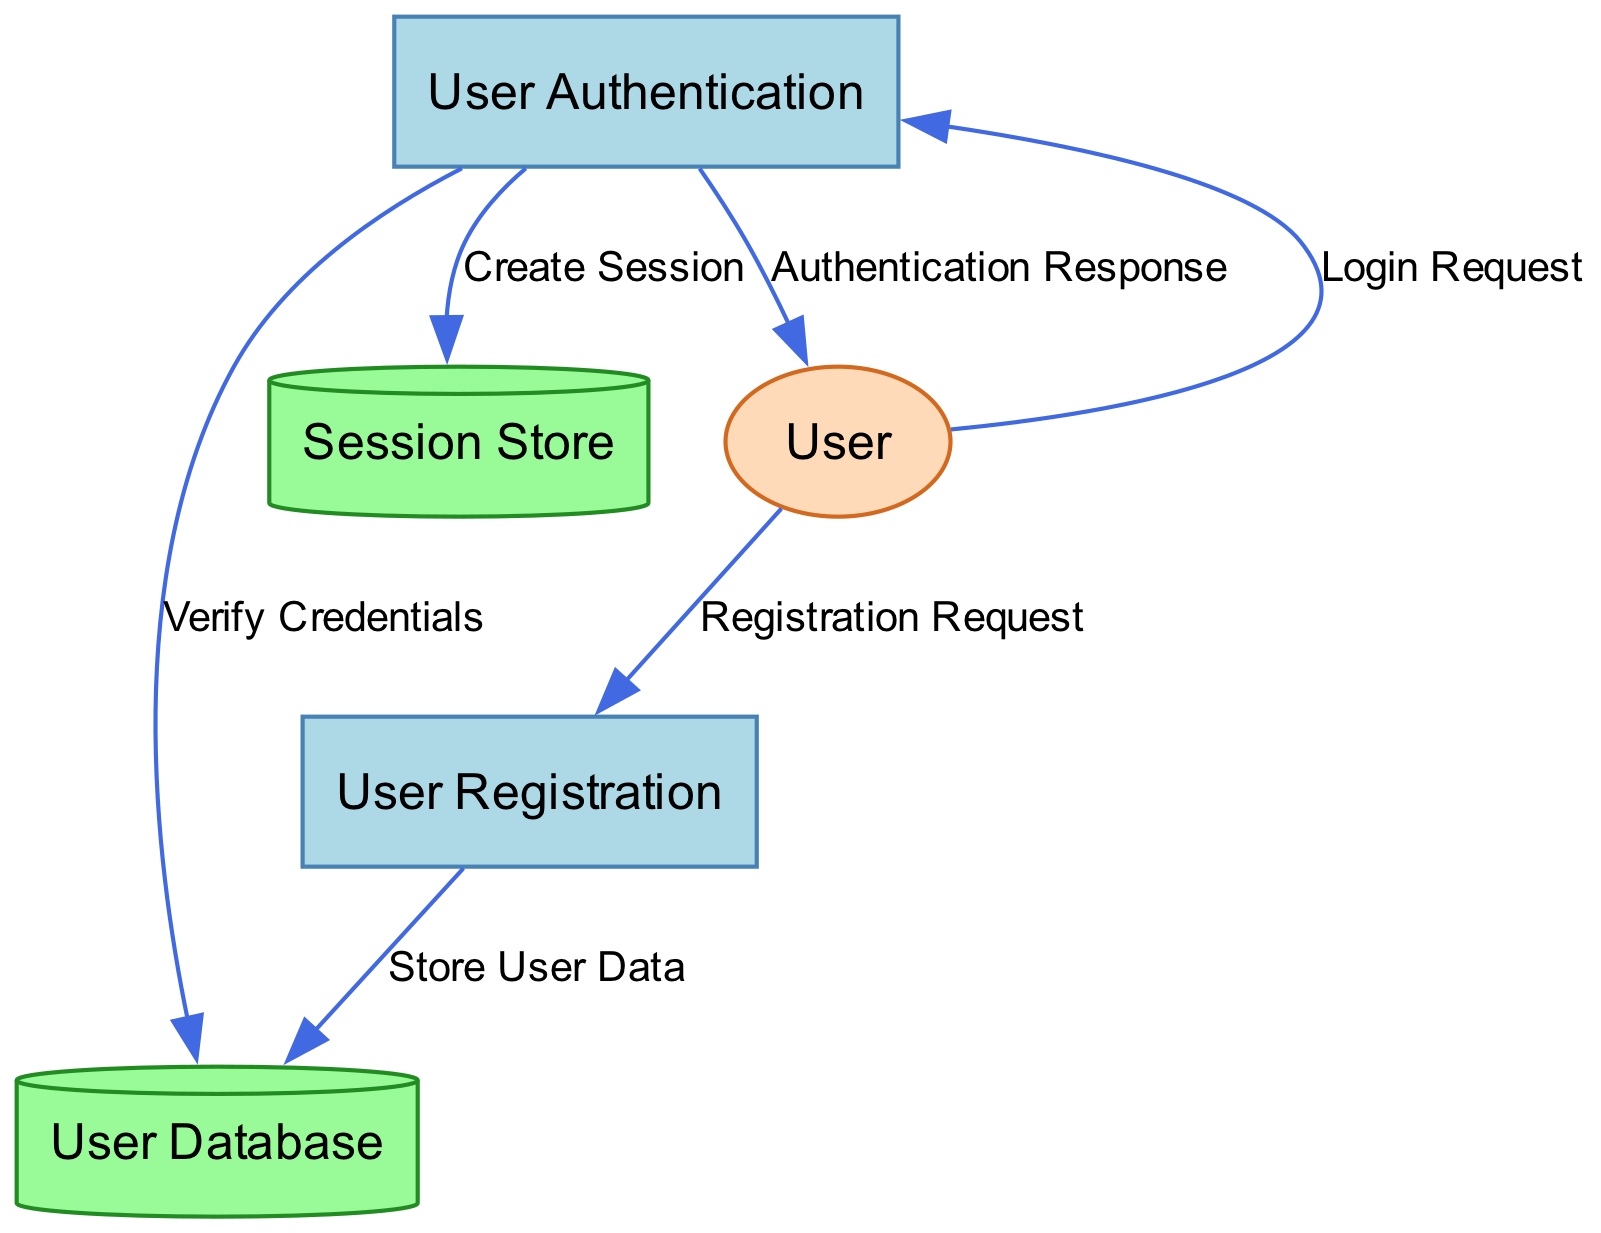What is the first process in the diagram? The first process listed in the diagram is "User Registration," which is indicated as the process with ID "1."
Answer: User Registration How many data stores are represented in the diagram? The diagram includes two data stores: "User Database" and "Session Store," which can be counted directly from the data store section.
Answer: 2 What does the user provide during the registration process? The diagram specifies that the user provides a "Registration Request," which consists of the necessary details to register for the platform.
Answer: Registration Request What happens to user data after registration? After the user registration is validated, the user data, including the encrypted password, is stored in the "User Database." Thus, the flow from process "1" to data store "DS1" confirms this storage action.
Answer: Store User Data Which process verifies user credentials? The "User Authentication" process, indicated as process "2," is responsible for verifying user credentials during the login attempt based on the data flow from external entity "EE1" to process "2."
Answer: User Authentication How does the authentication process inform the user of the result? The diagram shows that the "Authentication Response" data flow from process "2" to the user entity "EE1" provides feedback on the login attempt's success or failure.
Answer: Authentication Response What is created upon successful user authentication? Upon successful authentication, a "Session Token" is created, as indicated by the data flow leading to the "Session Store" (DS2) from process "2."
Answer: Session Token What is the relationship between the session store and active sessions? The "Session Store" maintains active user session tokens, as described in the data store's explanation in the diagram, suggesting it plays a crucial role in session management.
Answer: Maintains active user sessions What data flow connects the user's login request to the authentication process? The flow labeled "Login Request" connects the external entity "User" (EE1) to the process "User Authentication" (2), showing how the user initiates authentication.
Answer: Login Request 